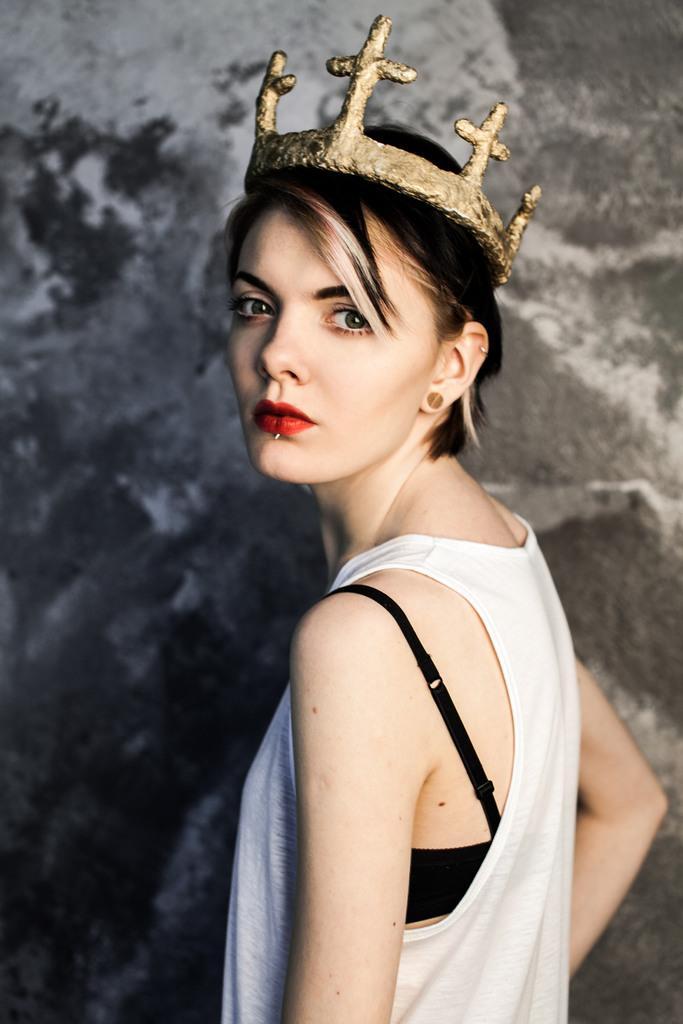Please provide a concise description of this image. In front of the image there is a person wearing a crown. Behind her there is a wall. 